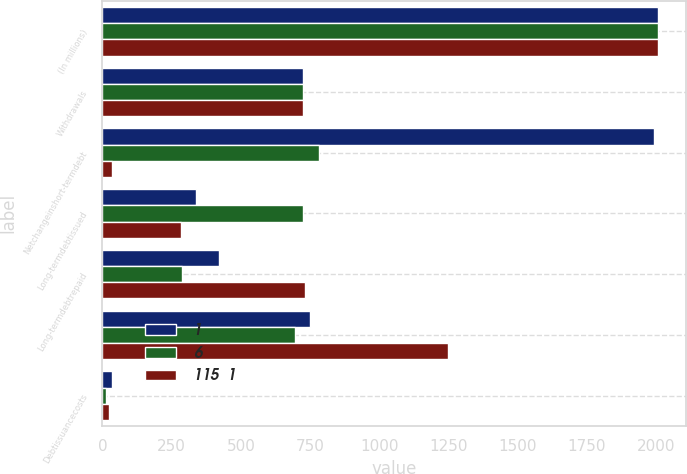<chart> <loc_0><loc_0><loc_500><loc_500><stacked_bar_chart><ecel><fcel>(In millions)<fcel>Withdrawals<fcel>Netchangeinshort-termdebt<fcel>Long-termdebtissued<fcel>Long-termdebtrepaid<fcel>Unnamed: 6<fcel>Debtissuancecosts<nl><fcel>1<fcel>2008<fcel>726<fcel>1992<fcel>339<fcel>422<fcel>750<fcel>34<nl><fcel>6<fcel>2007<fcel>726<fcel>782<fcel>726<fcel>286<fcel>694<fcel>14<nl><fcel>115  1<fcel>2006<fcel>726<fcel>35<fcel>284<fcel>732<fcel>1248<fcel>25<nl></chart> 